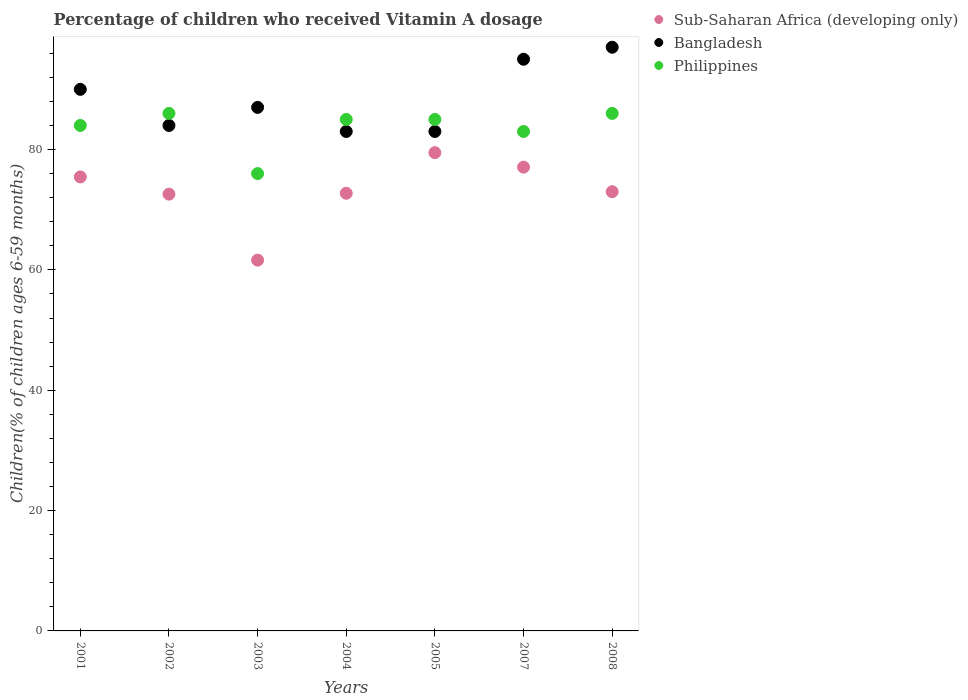What is the percentage of children who received Vitamin A dosage in Sub-Saharan Africa (developing only) in 2003?
Your answer should be very brief. 61.62. Across all years, what is the maximum percentage of children who received Vitamin A dosage in Bangladesh?
Offer a very short reply. 97. Across all years, what is the minimum percentage of children who received Vitamin A dosage in Sub-Saharan Africa (developing only)?
Give a very brief answer. 61.62. What is the total percentage of children who received Vitamin A dosage in Philippines in the graph?
Your response must be concise. 585. What is the difference between the percentage of children who received Vitamin A dosage in Sub-Saharan Africa (developing only) in 2001 and that in 2008?
Your response must be concise. 2.45. What is the difference between the percentage of children who received Vitamin A dosage in Philippines in 2003 and the percentage of children who received Vitamin A dosage in Sub-Saharan Africa (developing only) in 2001?
Give a very brief answer. 0.56. What is the average percentage of children who received Vitamin A dosage in Philippines per year?
Make the answer very short. 83.57. In the year 2002, what is the difference between the percentage of children who received Vitamin A dosage in Philippines and percentage of children who received Vitamin A dosage in Sub-Saharan Africa (developing only)?
Provide a short and direct response. 13.42. What is the ratio of the percentage of children who received Vitamin A dosage in Sub-Saharan Africa (developing only) in 2003 to that in 2007?
Keep it short and to the point. 0.8. Is the percentage of children who received Vitamin A dosage in Bangladesh in 2004 less than that in 2005?
Give a very brief answer. No. Is the difference between the percentage of children who received Vitamin A dosage in Philippines in 2001 and 2004 greater than the difference between the percentage of children who received Vitamin A dosage in Sub-Saharan Africa (developing only) in 2001 and 2004?
Keep it short and to the point. No. What is the difference between the highest and the second highest percentage of children who received Vitamin A dosage in Philippines?
Make the answer very short. 0. Is the sum of the percentage of children who received Vitamin A dosage in Sub-Saharan Africa (developing only) in 2003 and 2005 greater than the maximum percentage of children who received Vitamin A dosage in Bangladesh across all years?
Offer a terse response. Yes. Is it the case that in every year, the sum of the percentage of children who received Vitamin A dosage in Philippines and percentage of children who received Vitamin A dosage in Sub-Saharan Africa (developing only)  is greater than the percentage of children who received Vitamin A dosage in Bangladesh?
Your answer should be very brief. Yes. Is the percentage of children who received Vitamin A dosage in Philippines strictly greater than the percentage of children who received Vitamin A dosage in Bangladesh over the years?
Your answer should be very brief. No. Is the percentage of children who received Vitamin A dosage in Bangladesh strictly less than the percentage of children who received Vitamin A dosage in Sub-Saharan Africa (developing only) over the years?
Make the answer very short. No. How many years are there in the graph?
Your response must be concise. 7. What is the difference between two consecutive major ticks on the Y-axis?
Provide a short and direct response. 20. Are the values on the major ticks of Y-axis written in scientific E-notation?
Your answer should be very brief. No. Does the graph contain any zero values?
Your answer should be very brief. No. Does the graph contain grids?
Your answer should be compact. No. Where does the legend appear in the graph?
Ensure brevity in your answer.  Top right. What is the title of the graph?
Provide a short and direct response. Percentage of children who received Vitamin A dosage. Does "Haiti" appear as one of the legend labels in the graph?
Keep it short and to the point. No. What is the label or title of the Y-axis?
Your answer should be very brief. Children(% of children ages 6-59 months). What is the Children(% of children ages 6-59 months) in Sub-Saharan Africa (developing only) in 2001?
Your answer should be very brief. 75.44. What is the Children(% of children ages 6-59 months) in Bangladesh in 2001?
Keep it short and to the point. 90. What is the Children(% of children ages 6-59 months) of Sub-Saharan Africa (developing only) in 2002?
Provide a succinct answer. 72.58. What is the Children(% of children ages 6-59 months) in Bangladesh in 2002?
Offer a terse response. 84. What is the Children(% of children ages 6-59 months) of Sub-Saharan Africa (developing only) in 2003?
Make the answer very short. 61.62. What is the Children(% of children ages 6-59 months) in Bangladesh in 2003?
Provide a succinct answer. 87. What is the Children(% of children ages 6-59 months) in Philippines in 2003?
Your answer should be compact. 76. What is the Children(% of children ages 6-59 months) of Sub-Saharan Africa (developing only) in 2004?
Keep it short and to the point. 72.73. What is the Children(% of children ages 6-59 months) of Sub-Saharan Africa (developing only) in 2005?
Provide a succinct answer. 79.48. What is the Children(% of children ages 6-59 months) in Philippines in 2005?
Make the answer very short. 85. What is the Children(% of children ages 6-59 months) in Sub-Saharan Africa (developing only) in 2007?
Your response must be concise. 77.07. What is the Children(% of children ages 6-59 months) in Sub-Saharan Africa (developing only) in 2008?
Your answer should be compact. 72.99. What is the Children(% of children ages 6-59 months) of Bangladesh in 2008?
Offer a very short reply. 97. Across all years, what is the maximum Children(% of children ages 6-59 months) in Sub-Saharan Africa (developing only)?
Provide a succinct answer. 79.48. Across all years, what is the maximum Children(% of children ages 6-59 months) in Bangladesh?
Your answer should be very brief. 97. Across all years, what is the minimum Children(% of children ages 6-59 months) of Sub-Saharan Africa (developing only)?
Ensure brevity in your answer.  61.62. What is the total Children(% of children ages 6-59 months) of Sub-Saharan Africa (developing only) in the graph?
Give a very brief answer. 511.92. What is the total Children(% of children ages 6-59 months) in Bangladesh in the graph?
Offer a very short reply. 619. What is the total Children(% of children ages 6-59 months) in Philippines in the graph?
Ensure brevity in your answer.  585. What is the difference between the Children(% of children ages 6-59 months) in Sub-Saharan Africa (developing only) in 2001 and that in 2002?
Offer a very short reply. 2.86. What is the difference between the Children(% of children ages 6-59 months) of Bangladesh in 2001 and that in 2002?
Keep it short and to the point. 6. What is the difference between the Children(% of children ages 6-59 months) of Sub-Saharan Africa (developing only) in 2001 and that in 2003?
Your response must be concise. 13.83. What is the difference between the Children(% of children ages 6-59 months) of Philippines in 2001 and that in 2003?
Give a very brief answer. 8. What is the difference between the Children(% of children ages 6-59 months) in Sub-Saharan Africa (developing only) in 2001 and that in 2004?
Offer a terse response. 2.71. What is the difference between the Children(% of children ages 6-59 months) in Bangladesh in 2001 and that in 2004?
Your answer should be very brief. 7. What is the difference between the Children(% of children ages 6-59 months) of Philippines in 2001 and that in 2004?
Keep it short and to the point. -1. What is the difference between the Children(% of children ages 6-59 months) in Sub-Saharan Africa (developing only) in 2001 and that in 2005?
Offer a terse response. -4.03. What is the difference between the Children(% of children ages 6-59 months) of Bangladesh in 2001 and that in 2005?
Make the answer very short. 7. What is the difference between the Children(% of children ages 6-59 months) of Sub-Saharan Africa (developing only) in 2001 and that in 2007?
Your response must be concise. -1.63. What is the difference between the Children(% of children ages 6-59 months) in Bangladesh in 2001 and that in 2007?
Offer a terse response. -5. What is the difference between the Children(% of children ages 6-59 months) of Philippines in 2001 and that in 2007?
Provide a short and direct response. 1. What is the difference between the Children(% of children ages 6-59 months) of Sub-Saharan Africa (developing only) in 2001 and that in 2008?
Offer a terse response. 2.45. What is the difference between the Children(% of children ages 6-59 months) in Bangladesh in 2001 and that in 2008?
Your response must be concise. -7. What is the difference between the Children(% of children ages 6-59 months) in Philippines in 2001 and that in 2008?
Provide a short and direct response. -2. What is the difference between the Children(% of children ages 6-59 months) in Sub-Saharan Africa (developing only) in 2002 and that in 2003?
Keep it short and to the point. 10.96. What is the difference between the Children(% of children ages 6-59 months) in Philippines in 2002 and that in 2003?
Make the answer very short. 10. What is the difference between the Children(% of children ages 6-59 months) in Sub-Saharan Africa (developing only) in 2002 and that in 2004?
Your response must be concise. -0.15. What is the difference between the Children(% of children ages 6-59 months) in Philippines in 2002 and that in 2004?
Offer a very short reply. 1. What is the difference between the Children(% of children ages 6-59 months) of Sub-Saharan Africa (developing only) in 2002 and that in 2005?
Keep it short and to the point. -6.9. What is the difference between the Children(% of children ages 6-59 months) in Sub-Saharan Africa (developing only) in 2002 and that in 2007?
Keep it short and to the point. -4.49. What is the difference between the Children(% of children ages 6-59 months) of Philippines in 2002 and that in 2007?
Offer a terse response. 3. What is the difference between the Children(% of children ages 6-59 months) of Sub-Saharan Africa (developing only) in 2002 and that in 2008?
Your answer should be very brief. -0.41. What is the difference between the Children(% of children ages 6-59 months) of Bangladesh in 2002 and that in 2008?
Provide a short and direct response. -13. What is the difference between the Children(% of children ages 6-59 months) in Philippines in 2002 and that in 2008?
Your answer should be very brief. 0. What is the difference between the Children(% of children ages 6-59 months) in Sub-Saharan Africa (developing only) in 2003 and that in 2004?
Provide a short and direct response. -11.11. What is the difference between the Children(% of children ages 6-59 months) in Bangladesh in 2003 and that in 2004?
Keep it short and to the point. 4. What is the difference between the Children(% of children ages 6-59 months) of Philippines in 2003 and that in 2004?
Keep it short and to the point. -9. What is the difference between the Children(% of children ages 6-59 months) of Sub-Saharan Africa (developing only) in 2003 and that in 2005?
Ensure brevity in your answer.  -17.86. What is the difference between the Children(% of children ages 6-59 months) of Bangladesh in 2003 and that in 2005?
Provide a short and direct response. 4. What is the difference between the Children(% of children ages 6-59 months) of Sub-Saharan Africa (developing only) in 2003 and that in 2007?
Provide a succinct answer. -15.45. What is the difference between the Children(% of children ages 6-59 months) of Bangladesh in 2003 and that in 2007?
Your response must be concise. -8. What is the difference between the Children(% of children ages 6-59 months) of Philippines in 2003 and that in 2007?
Give a very brief answer. -7. What is the difference between the Children(% of children ages 6-59 months) in Sub-Saharan Africa (developing only) in 2003 and that in 2008?
Offer a very short reply. -11.37. What is the difference between the Children(% of children ages 6-59 months) of Philippines in 2003 and that in 2008?
Offer a terse response. -10. What is the difference between the Children(% of children ages 6-59 months) of Sub-Saharan Africa (developing only) in 2004 and that in 2005?
Offer a terse response. -6.75. What is the difference between the Children(% of children ages 6-59 months) in Sub-Saharan Africa (developing only) in 2004 and that in 2007?
Give a very brief answer. -4.34. What is the difference between the Children(% of children ages 6-59 months) in Sub-Saharan Africa (developing only) in 2004 and that in 2008?
Provide a succinct answer. -0.26. What is the difference between the Children(% of children ages 6-59 months) in Sub-Saharan Africa (developing only) in 2005 and that in 2007?
Provide a short and direct response. 2.41. What is the difference between the Children(% of children ages 6-59 months) in Bangladesh in 2005 and that in 2007?
Make the answer very short. -12. What is the difference between the Children(% of children ages 6-59 months) of Sub-Saharan Africa (developing only) in 2005 and that in 2008?
Keep it short and to the point. 6.49. What is the difference between the Children(% of children ages 6-59 months) of Philippines in 2005 and that in 2008?
Make the answer very short. -1. What is the difference between the Children(% of children ages 6-59 months) in Sub-Saharan Africa (developing only) in 2007 and that in 2008?
Your response must be concise. 4.08. What is the difference between the Children(% of children ages 6-59 months) in Bangladesh in 2007 and that in 2008?
Provide a short and direct response. -2. What is the difference between the Children(% of children ages 6-59 months) in Philippines in 2007 and that in 2008?
Provide a succinct answer. -3. What is the difference between the Children(% of children ages 6-59 months) in Sub-Saharan Africa (developing only) in 2001 and the Children(% of children ages 6-59 months) in Bangladesh in 2002?
Your answer should be very brief. -8.56. What is the difference between the Children(% of children ages 6-59 months) of Sub-Saharan Africa (developing only) in 2001 and the Children(% of children ages 6-59 months) of Philippines in 2002?
Provide a succinct answer. -10.56. What is the difference between the Children(% of children ages 6-59 months) of Sub-Saharan Africa (developing only) in 2001 and the Children(% of children ages 6-59 months) of Bangladesh in 2003?
Your response must be concise. -11.56. What is the difference between the Children(% of children ages 6-59 months) in Sub-Saharan Africa (developing only) in 2001 and the Children(% of children ages 6-59 months) in Philippines in 2003?
Make the answer very short. -0.56. What is the difference between the Children(% of children ages 6-59 months) of Bangladesh in 2001 and the Children(% of children ages 6-59 months) of Philippines in 2003?
Give a very brief answer. 14. What is the difference between the Children(% of children ages 6-59 months) in Sub-Saharan Africa (developing only) in 2001 and the Children(% of children ages 6-59 months) in Bangladesh in 2004?
Your answer should be very brief. -7.56. What is the difference between the Children(% of children ages 6-59 months) of Sub-Saharan Africa (developing only) in 2001 and the Children(% of children ages 6-59 months) of Philippines in 2004?
Your response must be concise. -9.56. What is the difference between the Children(% of children ages 6-59 months) of Bangladesh in 2001 and the Children(% of children ages 6-59 months) of Philippines in 2004?
Your answer should be compact. 5. What is the difference between the Children(% of children ages 6-59 months) of Sub-Saharan Africa (developing only) in 2001 and the Children(% of children ages 6-59 months) of Bangladesh in 2005?
Your answer should be very brief. -7.56. What is the difference between the Children(% of children ages 6-59 months) in Sub-Saharan Africa (developing only) in 2001 and the Children(% of children ages 6-59 months) in Philippines in 2005?
Give a very brief answer. -9.56. What is the difference between the Children(% of children ages 6-59 months) in Sub-Saharan Africa (developing only) in 2001 and the Children(% of children ages 6-59 months) in Bangladesh in 2007?
Ensure brevity in your answer.  -19.56. What is the difference between the Children(% of children ages 6-59 months) of Sub-Saharan Africa (developing only) in 2001 and the Children(% of children ages 6-59 months) of Philippines in 2007?
Offer a terse response. -7.56. What is the difference between the Children(% of children ages 6-59 months) of Sub-Saharan Africa (developing only) in 2001 and the Children(% of children ages 6-59 months) of Bangladesh in 2008?
Provide a succinct answer. -21.56. What is the difference between the Children(% of children ages 6-59 months) in Sub-Saharan Africa (developing only) in 2001 and the Children(% of children ages 6-59 months) in Philippines in 2008?
Provide a succinct answer. -10.56. What is the difference between the Children(% of children ages 6-59 months) of Sub-Saharan Africa (developing only) in 2002 and the Children(% of children ages 6-59 months) of Bangladesh in 2003?
Your answer should be very brief. -14.42. What is the difference between the Children(% of children ages 6-59 months) in Sub-Saharan Africa (developing only) in 2002 and the Children(% of children ages 6-59 months) in Philippines in 2003?
Make the answer very short. -3.42. What is the difference between the Children(% of children ages 6-59 months) in Sub-Saharan Africa (developing only) in 2002 and the Children(% of children ages 6-59 months) in Bangladesh in 2004?
Keep it short and to the point. -10.42. What is the difference between the Children(% of children ages 6-59 months) of Sub-Saharan Africa (developing only) in 2002 and the Children(% of children ages 6-59 months) of Philippines in 2004?
Keep it short and to the point. -12.42. What is the difference between the Children(% of children ages 6-59 months) of Bangladesh in 2002 and the Children(% of children ages 6-59 months) of Philippines in 2004?
Keep it short and to the point. -1. What is the difference between the Children(% of children ages 6-59 months) in Sub-Saharan Africa (developing only) in 2002 and the Children(% of children ages 6-59 months) in Bangladesh in 2005?
Ensure brevity in your answer.  -10.42. What is the difference between the Children(% of children ages 6-59 months) in Sub-Saharan Africa (developing only) in 2002 and the Children(% of children ages 6-59 months) in Philippines in 2005?
Provide a short and direct response. -12.42. What is the difference between the Children(% of children ages 6-59 months) in Bangladesh in 2002 and the Children(% of children ages 6-59 months) in Philippines in 2005?
Provide a succinct answer. -1. What is the difference between the Children(% of children ages 6-59 months) in Sub-Saharan Africa (developing only) in 2002 and the Children(% of children ages 6-59 months) in Bangladesh in 2007?
Your response must be concise. -22.42. What is the difference between the Children(% of children ages 6-59 months) of Sub-Saharan Africa (developing only) in 2002 and the Children(% of children ages 6-59 months) of Philippines in 2007?
Provide a short and direct response. -10.42. What is the difference between the Children(% of children ages 6-59 months) in Sub-Saharan Africa (developing only) in 2002 and the Children(% of children ages 6-59 months) in Bangladesh in 2008?
Your answer should be very brief. -24.42. What is the difference between the Children(% of children ages 6-59 months) in Sub-Saharan Africa (developing only) in 2002 and the Children(% of children ages 6-59 months) in Philippines in 2008?
Ensure brevity in your answer.  -13.42. What is the difference between the Children(% of children ages 6-59 months) of Sub-Saharan Africa (developing only) in 2003 and the Children(% of children ages 6-59 months) of Bangladesh in 2004?
Your answer should be compact. -21.38. What is the difference between the Children(% of children ages 6-59 months) of Sub-Saharan Africa (developing only) in 2003 and the Children(% of children ages 6-59 months) of Philippines in 2004?
Offer a terse response. -23.38. What is the difference between the Children(% of children ages 6-59 months) of Sub-Saharan Africa (developing only) in 2003 and the Children(% of children ages 6-59 months) of Bangladesh in 2005?
Your response must be concise. -21.38. What is the difference between the Children(% of children ages 6-59 months) in Sub-Saharan Africa (developing only) in 2003 and the Children(% of children ages 6-59 months) in Philippines in 2005?
Offer a very short reply. -23.38. What is the difference between the Children(% of children ages 6-59 months) of Bangladesh in 2003 and the Children(% of children ages 6-59 months) of Philippines in 2005?
Offer a terse response. 2. What is the difference between the Children(% of children ages 6-59 months) in Sub-Saharan Africa (developing only) in 2003 and the Children(% of children ages 6-59 months) in Bangladesh in 2007?
Your response must be concise. -33.38. What is the difference between the Children(% of children ages 6-59 months) of Sub-Saharan Africa (developing only) in 2003 and the Children(% of children ages 6-59 months) of Philippines in 2007?
Offer a terse response. -21.38. What is the difference between the Children(% of children ages 6-59 months) in Sub-Saharan Africa (developing only) in 2003 and the Children(% of children ages 6-59 months) in Bangladesh in 2008?
Give a very brief answer. -35.38. What is the difference between the Children(% of children ages 6-59 months) in Sub-Saharan Africa (developing only) in 2003 and the Children(% of children ages 6-59 months) in Philippines in 2008?
Your answer should be very brief. -24.38. What is the difference between the Children(% of children ages 6-59 months) in Bangladesh in 2003 and the Children(% of children ages 6-59 months) in Philippines in 2008?
Provide a short and direct response. 1. What is the difference between the Children(% of children ages 6-59 months) in Sub-Saharan Africa (developing only) in 2004 and the Children(% of children ages 6-59 months) in Bangladesh in 2005?
Your answer should be very brief. -10.27. What is the difference between the Children(% of children ages 6-59 months) in Sub-Saharan Africa (developing only) in 2004 and the Children(% of children ages 6-59 months) in Philippines in 2005?
Ensure brevity in your answer.  -12.27. What is the difference between the Children(% of children ages 6-59 months) in Bangladesh in 2004 and the Children(% of children ages 6-59 months) in Philippines in 2005?
Provide a succinct answer. -2. What is the difference between the Children(% of children ages 6-59 months) of Sub-Saharan Africa (developing only) in 2004 and the Children(% of children ages 6-59 months) of Bangladesh in 2007?
Give a very brief answer. -22.27. What is the difference between the Children(% of children ages 6-59 months) of Sub-Saharan Africa (developing only) in 2004 and the Children(% of children ages 6-59 months) of Philippines in 2007?
Your answer should be very brief. -10.27. What is the difference between the Children(% of children ages 6-59 months) of Bangladesh in 2004 and the Children(% of children ages 6-59 months) of Philippines in 2007?
Keep it short and to the point. 0. What is the difference between the Children(% of children ages 6-59 months) of Sub-Saharan Africa (developing only) in 2004 and the Children(% of children ages 6-59 months) of Bangladesh in 2008?
Provide a succinct answer. -24.27. What is the difference between the Children(% of children ages 6-59 months) of Sub-Saharan Africa (developing only) in 2004 and the Children(% of children ages 6-59 months) of Philippines in 2008?
Offer a terse response. -13.27. What is the difference between the Children(% of children ages 6-59 months) in Sub-Saharan Africa (developing only) in 2005 and the Children(% of children ages 6-59 months) in Bangladesh in 2007?
Provide a short and direct response. -15.52. What is the difference between the Children(% of children ages 6-59 months) in Sub-Saharan Africa (developing only) in 2005 and the Children(% of children ages 6-59 months) in Philippines in 2007?
Give a very brief answer. -3.52. What is the difference between the Children(% of children ages 6-59 months) of Sub-Saharan Africa (developing only) in 2005 and the Children(% of children ages 6-59 months) of Bangladesh in 2008?
Provide a succinct answer. -17.52. What is the difference between the Children(% of children ages 6-59 months) in Sub-Saharan Africa (developing only) in 2005 and the Children(% of children ages 6-59 months) in Philippines in 2008?
Give a very brief answer. -6.52. What is the difference between the Children(% of children ages 6-59 months) in Bangladesh in 2005 and the Children(% of children ages 6-59 months) in Philippines in 2008?
Make the answer very short. -3. What is the difference between the Children(% of children ages 6-59 months) in Sub-Saharan Africa (developing only) in 2007 and the Children(% of children ages 6-59 months) in Bangladesh in 2008?
Offer a very short reply. -19.93. What is the difference between the Children(% of children ages 6-59 months) in Sub-Saharan Africa (developing only) in 2007 and the Children(% of children ages 6-59 months) in Philippines in 2008?
Keep it short and to the point. -8.93. What is the difference between the Children(% of children ages 6-59 months) in Bangladesh in 2007 and the Children(% of children ages 6-59 months) in Philippines in 2008?
Keep it short and to the point. 9. What is the average Children(% of children ages 6-59 months) in Sub-Saharan Africa (developing only) per year?
Offer a terse response. 73.13. What is the average Children(% of children ages 6-59 months) of Bangladesh per year?
Keep it short and to the point. 88.43. What is the average Children(% of children ages 6-59 months) of Philippines per year?
Offer a terse response. 83.57. In the year 2001, what is the difference between the Children(% of children ages 6-59 months) in Sub-Saharan Africa (developing only) and Children(% of children ages 6-59 months) in Bangladesh?
Give a very brief answer. -14.56. In the year 2001, what is the difference between the Children(% of children ages 6-59 months) of Sub-Saharan Africa (developing only) and Children(% of children ages 6-59 months) of Philippines?
Provide a succinct answer. -8.56. In the year 2001, what is the difference between the Children(% of children ages 6-59 months) in Bangladesh and Children(% of children ages 6-59 months) in Philippines?
Keep it short and to the point. 6. In the year 2002, what is the difference between the Children(% of children ages 6-59 months) of Sub-Saharan Africa (developing only) and Children(% of children ages 6-59 months) of Bangladesh?
Provide a short and direct response. -11.42. In the year 2002, what is the difference between the Children(% of children ages 6-59 months) in Sub-Saharan Africa (developing only) and Children(% of children ages 6-59 months) in Philippines?
Your answer should be very brief. -13.42. In the year 2003, what is the difference between the Children(% of children ages 6-59 months) in Sub-Saharan Africa (developing only) and Children(% of children ages 6-59 months) in Bangladesh?
Keep it short and to the point. -25.38. In the year 2003, what is the difference between the Children(% of children ages 6-59 months) of Sub-Saharan Africa (developing only) and Children(% of children ages 6-59 months) of Philippines?
Your response must be concise. -14.38. In the year 2003, what is the difference between the Children(% of children ages 6-59 months) of Bangladesh and Children(% of children ages 6-59 months) of Philippines?
Provide a succinct answer. 11. In the year 2004, what is the difference between the Children(% of children ages 6-59 months) of Sub-Saharan Africa (developing only) and Children(% of children ages 6-59 months) of Bangladesh?
Make the answer very short. -10.27. In the year 2004, what is the difference between the Children(% of children ages 6-59 months) in Sub-Saharan Africa (developing only) and Children(% of children ages 6-59 months) in Philippines?
Ensure brevity in your answer.  -12.27. In the year 2005, what is the difference between the Children(% of children ages 6-59 months) in Sub-Saharan Africa (developing only) and Children(% of children ages 6-59 months) in Bangladesh?
Provide a succinct answer. -3.52. In the year 2005, what is the difference between the Children(% of children ages 6-59 months) in Sub-Saharan Africa (developing only) and Children(% of children ages 6-59 months) in Philippines?
Offer a terse response. -5.52. In the year 2005, what is the difference between the Children(% of children ages 6-59 months) in Bangladesh and Children(% of children ages 6-59 months) in Philippines?
Make the answer very short. -2. In the year 2007, what is the difference between the Children(% of children ages 6-59 months) in Sub-Saharan Africa (developing only) and Children(% of children ages 6-59 months) in Bangladesh?
Offer a very short reply. -17.93. In the year 2007, what is the difference between the Children(% of children ages 6-59 months) of Sub-Saharan Africa (developing only) and Children(% of children ages 6-59 months) of Philippines?
Your answer should be compact. -5.93. In the year 2007, what is the difference between the Children(% of children ages 6-59 months) in Bangladesh and Children(% of children ages 6-59 months) in Philippines?
Provide a succinct answer. 12. In the year 2008, what is the difference between the Children(% of children ages 6-59 months) in Sub-Saharan Africa (developing only) and Children(% of children ages 6-59 months) in Bangladesh?
Your answer should be very brief. -24.01. In the year 2008, what is the difference between the Children(% of children ages 6-59 months) in Sub-Saharan Africa (developing only) and Children(% of children ages 6-59 months) in Philippines?
Provide a succinct answer. -13.01. What is the ratio of the Children(% of children ages 6-59 months) of Sub-Saharan Africa (developing only) in 2001 to that in 2002?
Your response must be concise. 1.04. What is the ratio of the Children(% of children ages 6-59 months) in Bangladesh in 2001 to that in 2002?
Your answer should be very brief. 1.07. What is the ratio of the Children(% of children ages 6-59 months) in Philippines in 2001 to that in 2002?
Your response must be concise. 0.98. What is the ratio of the Children(% of children ages 6-59 months) of Sub-Saharan Africa (developing only) in 2001 to that in 2003?
Give a very brief answer. 1.22. What is the ratio of the Children(% of children ages 6-59 months) of Bangladesh in 2001 to that in 2003?
Ensure brevity in your answer.  1.03. What is the ratio of the Children(% of children ages 6-59 months) in Philippines in 2001 to that in 2003?
Make the answer very short. 1.11. What is the ratio of the Children(% of children ages 6-59 months) of Sub-Saharan Africa (developing only) in 2001 to that in 2004?
Provide a short and direct response. 1.04. What is the ratio of the Children(% of children ages 6-59 months) in Bangladesh in 2001 to that in 2004?
Your answer should be compact. 1.08. What is the ratio of the Children(% of children ages 6-59 months) of Philippines in 2001 to that in 2004?
Your answer should be compact. 0.99. What is the ratio of the Children(% of children ages 6-59 months) in Sub-Saharan Africa (developing only) in 2001 to that in 2005?
Your response must be concise. 0.95. What is the ratio of the Children(% of children ages 6-59 months) of Bangladesh in 2001 to that in 2005?
Provide a short and direct response. 1.08. What is the ratio of the Children(% of children ages 6-59 months) of Philippines in 2001 to that in 2005?
Offer a terse response. 0.99. What is the ratio of the Children(% of children ages 6-59 months) of Sub-Saharan Africa (developing only) in 2001 to that in 2007?
Your response must be concise. 0.98. What is the ratio of the Children(% of children ages 6-59 months) in Bangladesh in 2001 to that in 2007?
Provide a short and direct response. 0.95. What is the ratio of the Children(% of children ages 6-59 months) of Sub-Saharan Africa (developing only) in 2001 to that in 2008?
Your answer should be very brief. 1.03. What is the ratio of the Children(% of children ages 6-59 months) of Bangladesh in 2001 to that in 2008?
Your response must be concise. 0.93. What is the ratio of the Children(% of children ages 6-59 months) in Philippines in 2001 to that in 2008?
Provide a short and direct response. 0.98. What is the ratio of the Children(% of children ages 6-59 months) in Sub-Saharan Africa (developing only) in 2002 to that in 2003?
Provide a short and direct response. 1.18. What is the ratio of the Children(% of children ages 6-59 months) of Bangladesh in 2002 to that in 2003?
Offer a terse response. 0.97. What is the ratio of the Children(% of children ages 6-59 months) in Philippines in 2002 to that in 2003?
Provide a short and direct response. 1.13. What is the ratio of the Children(% of children ages 6-59 months) of Sub-Saharan Africa (developing only) in 2002 to that in 2004?
Your answer should be compact. 1. What is the ratio of the Children(% of children ages 6-59 months) in Philippines in 2002 to that in 2004?
Make the answer very short. 1.01. What is the ratio of the Children(% of children ages 6-59 months) in Sub-Saharan Africa (developing only) in 2002 to that in 2005?
Provide a succinct answer. 0.91. What is the ratio of the Children(% of children ages 6-59 months) of Philippines in 2002 to that in 2005?
Ensure brevity in your answer.  1.01. What is the ratio of the Children(% of children ages 6-59 months) in Sub-Saharan Africa (developing only) in 2002 to that in 2007?
Your answer should be compact. 0.94. What is the ratio of the Children(% of children ages 6-59 months) in Bangladesh in 2002 to that in 2007?
Your response must be concise. 0.88. What is the ratio of the Children(% of children ages 6-59 months) in Philippines in 2002 to that in 2007?
Ensure brevity in your answer.  1.04. What is the ratio of the Children(% of children ages 6-59 months) in Sub-Saharan Africa (developing only) in 2002 to that in 2008?
Your answer should be compact. 0.99. What is the ratio of the Children(% of children ages 6-59 months) in Bangladesh in 2002 to that in 2008?
Provide a succinct answer. 0.87. What is the ratio of the Children(% of children ages 6-59 months) of Sub-Saharan Africa (developing only) in 2003 to that in 2004?
Provide a short and direct response. 0.85. What is the ratio of the Children(% of children ages 6-59 months) in Bangladesh in 2003 to that in 2004?
Provide a succinct answer. 1.05. What is the ratio of the Children(% of children ages 6-59 months) in Philippines in 2003 to that in 2004?
Ensure brevity in your answer.  0.89. What is the ratio of the Children(% of children ages 6-59 months) of Sub-Saharan Africa (developing only) in 2003 to that in 2005?
Ensure brevity in your answer.  0.78. What is the ratio of the Children(% of children ages 6-59 months) of Bangladesh in 2003 to that in 2005?
Ensure brevity in your answer.  1.05. What is the ratio of the Children(% of children ages 6-59 months) in Philippines in 2003 to that in 2005?
Ensure brevity in your answer.  0.89. What is the ratio of the Children(% of children ages 6-59 months) of Sub-Saharan Africa (developing only) in 2003 to that in 2007?
Your response must be concise. 0.8. What is the ratio of the Children(% of children ages 6-59 months) of Bangladesh in 2003 to that in 2007?
Offer a terse response. 0.92. What is the ratio of the Children(% of children ages 6-59 months) of Philippines in 2003 to that in 2007?
Give a very brief answer. 0.92. What is the ratio of the Children(% of children ages 6-59 months) in Sub-Saharan Africa (developing only) in 2003 to that in 2008?
Your answer should be very brief. 0.84. What is the ratio of the Children(% of children ages 6-59 months) in Bangladesh in 2003 to that in 2008?
Ensure brevity in your answer.  0.9. What is the ratio of the Children(% of children ages 6-59 months) in Philippines in 2003 to that in 2008?
Your answer should be very brief. 0.88. What is the ratio of the Children(% of children ages 6-59 months) in Sub-Saharan Africa (developing only) in 2004 to that in 2005?
Ensure brevity in your answer.  0.92. What is the ratio of the Children(% of children ages 6-59 months) in Bangladesh in 2004 to that in 2005?
Your answer should be very brief. 1. What is the ratio of the Children(% of children ages 6-59 months) in Sub-Saharan Africa (developing only) in 2004 to that in 2007?
Your answer should be compact. 0.94. What is the ratio of the Children(% of children ages 6-59 months) in Bangladesh in 2004 to that in 2007?
Make the answer very short. 0.87. What is the ratio of the Children(% of children ages 6-59 months) of Philippines in 2004 to that in 2007?
Ensure brevity in your answer.  1.02. What is the ratio of the Children(% of children ages 6-59 months) of Sub-Saharan Africa (developing only) in 2004 to that in 2008?
Offer a very short reply. 1. What is the ratio of the Children(% of children ages 6-59 months) of Bangladesh in 2004 to that in 2008?
Your response must be concise. 0.86. What is the ratio of the Children(% of children ages 6-59 months) of Philippines in 2004 to that in 2008?
Offer a terse response. 0.99. What is the ratio of the Children(% of children ages 6-59 months) of Sub-Saharan Africa (developing only) in 2005 to that in 2007?
Your answer should be compact. 1.03. What is the ratio of the Children(% of children ages 6-59 months) in Bangladesh in 2005 to that in 2007?
Ensure brevity in your answer.  0.87. What is the ratio of the Children(% of children ages 6-59 months) in Philippines in 2005 to that in 2007?
Your answer should be very brief. 1.02. What is the ratio of the Children(% of children ages 6-59 months) of Sub-Saharan Africa (developing only) in 2005 to that in 2008?
Your response must be concise. 1.09. What is the ratio of the Children(% of children ages 6-59 months) of Bangladesh in 2005 to that in 2008?
Give a very brief answer. 0.86. What is the ratio of the Children(% of children ages 6-59 months) in Philippines in 2005 to that in 2008?
Offer a very short reply. 0.99. What is the ratio of the Children(% of children ages 6-59 months) of Sub-Saharan Africa (developing only) in 2007 to that in 2008?
Ensure brevity in your answer.  1.06. What is the ratio of the Children(% of children ages 6-59 months) in Bangladesh in 2007 to that in 2008?
Give a very brief answer. 0.98. What is the ratio of the Children(% of children ages 6-59 months) of Philippines in 2007 to that in 2008?
Give a very brief answer. 0.97. What is the difference between the highest and the second highest Children(% of children ages 6-59 months) of Sub-Saharan Africa (developing only)?
Keep it short and to the point. 2.41. What is the difference between the highest and the second highest Children(% of children ages 6-59 months) of Bangladesh?
Your answer should be compact. 2. What is the difference between the highest and the second highest Children(% of children ages 6-59 months) of Philippines?
Your response must be concise. 0. What is the difference between the highest and the lowest Children(% of children ages 6-59 months) of Sub-Saharan Africa (developing only)?
Provide a succinct answer. 17.86. What is the difference between the highest and the lowest Children(% of children ages 6-59 months) in Philippines?
Your response must be concise. 10. 